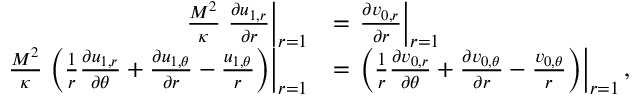Convert formula to latex. <formula><loc_0><loc_0><loc_500><loc_500>\begin{array} { r l } { \frac { M ^ { 2 } } { \kappa } \frac { \partial u _ { 1 , r } } { \partial r } \right | _ { r = 1 } } & { = \frac { \partial v _ { 0 , r } } { \partial r } \right | _ { r = 1 } } \\ { \frac { M ^ { 2 } } { \kappa } \left ( \frac { 1 } { r } \frac { \partial u _ { 1 , r } } { \partial \theta } + \frac { \partial u _ { 1 , \theta } } { \partial r } - \frac { u _ { 1 , \theta } } { r } \right ) \right | _ { r = 1 } } & { = \left ( \frac { 1 } { r } \frac { \partial v _ { 0 , r } } { \partial \theta } + \frac { \partial v _ { 0 , \theta } } { \partial r } - \frac { v _ { 0 , \theta } } { r } \right ) \right | _ { r = 1 } , } \end{array}</formula> 